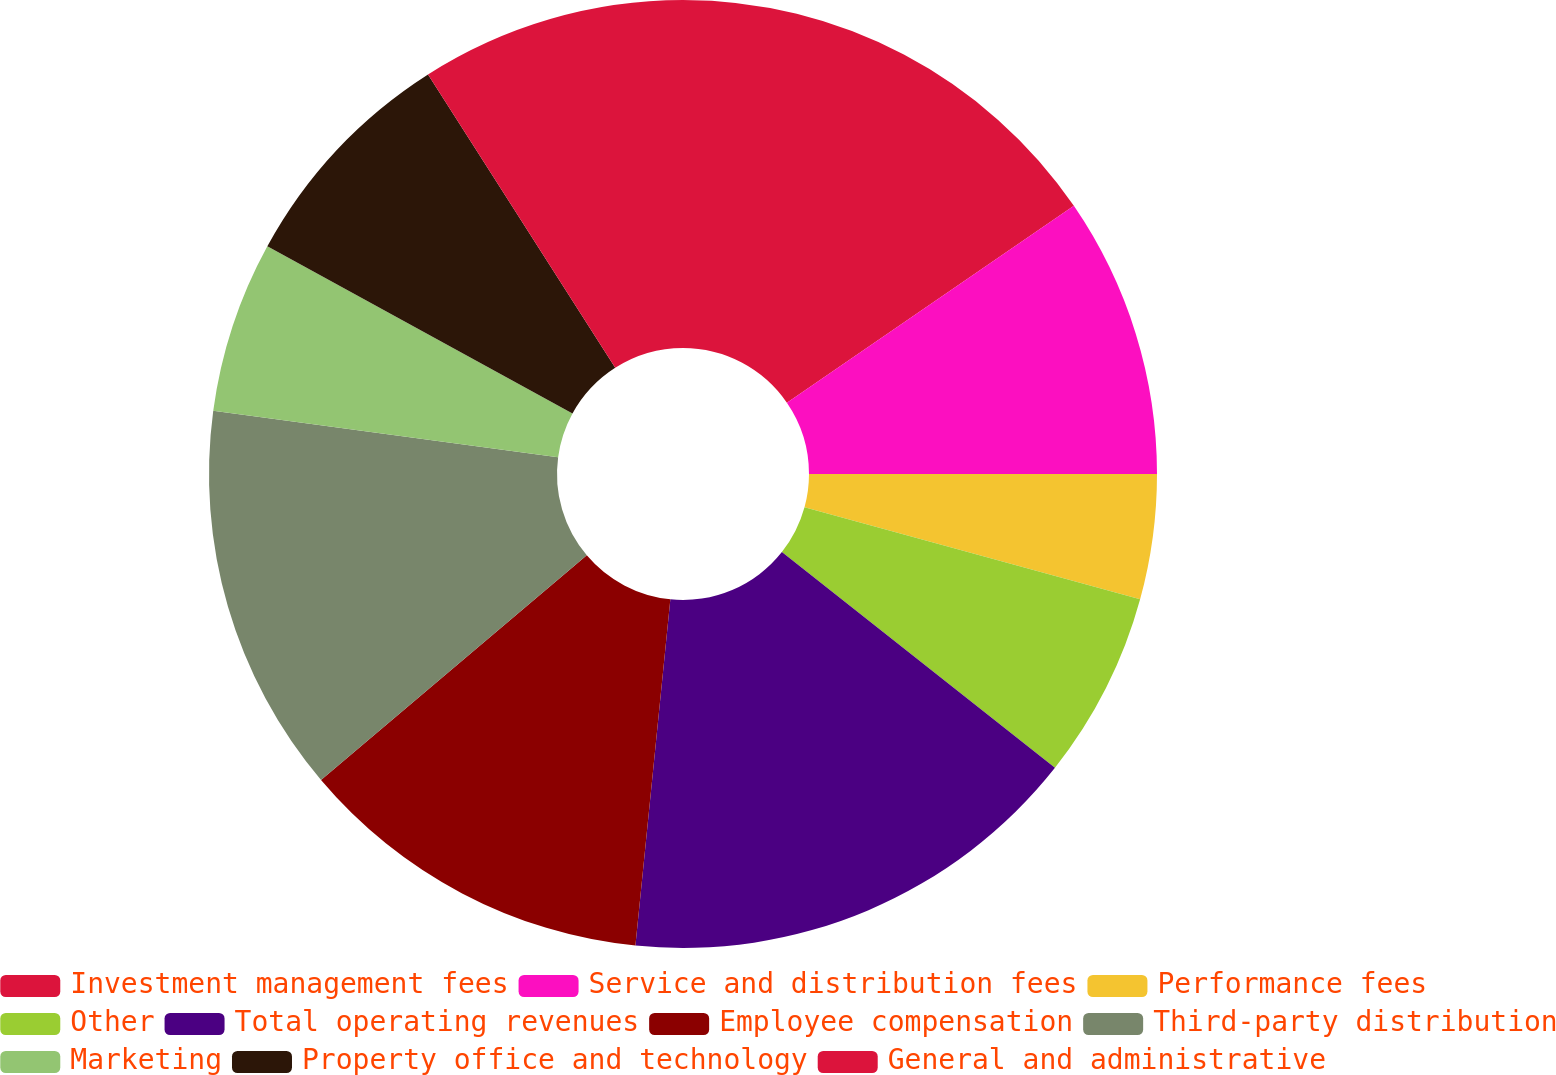Convert chart. <chart><loc_0><loc_0><loc_500><loc_500><pie_chart><fcel>Investment management fees<fcel>Service and distribution fees<fcel>Performance fees<fcel>Other<fcel>Total operating revenues<fcel>Employee compensation<fcel>Third-party distribution<fcel>Marketing<fcel>Property office and technology<fcel>General and administrative<nl><fcel>15.43%<fcel>9.57%<fcel>4.26%<fcel>6.38%<fcel>15.96%<fcel>12.23%<fcel>13.3%<fcel>5.85%<fcel>7.98%<fcel>9.04%<nl></chart> 